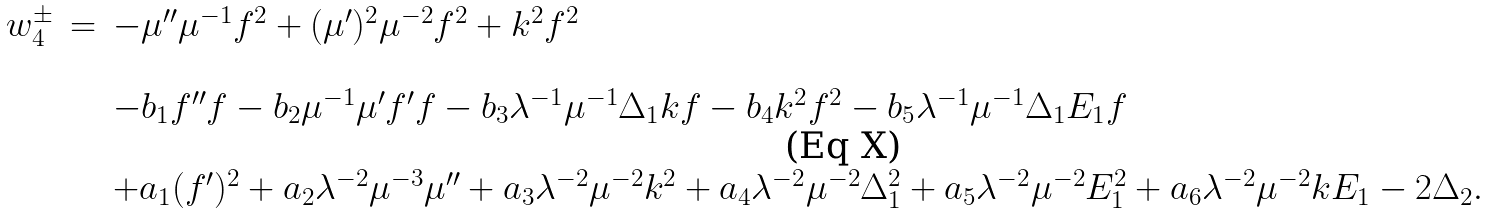Convert formula to latex. <formula><loc_0><loc_0><loc_500><loc_500>\begin{array} { l l l } w _ { 4 } ^ { \pm } & = & - \mu ^ { \prime \prime } \mu ^ { - 1 } f ^ { 2 } + ( \mu ^ { \prime } ) ^ { 2 } \mu ^ { - 2 } f ^ { 2 } + k ^ { 2 } f ^ { 2 } \\ & & \\ & & - b _ { 1 } f ^ { \prime \prime } f - b _ { 2 } \mu ^ { - 1 } \mu ^ { \prime } f ^ { \prime } f - b _ { 3 } \lambda ^ { - 1 } \mu ^ { - 1 } \Delta _ { 1 } k f - b _ { 4 } k ^ { 2 } f ^ { 2 } - b _ { 5 } \lambda ^ { - 1 } \mu ^ { - 1 } \Delta _ { 1 } E _ { 1 } f \\ & & \\ & & + a _ { 1 } ( f ^ { \prime } ) ^ { 2 } + a _ { 2 } \lambda ^ { - 2 } \mu ^ { - 3 } \mu ^ { \prime \prime } + a _ { 3 } \lambda ^ { - 2 } \mu ^ { - 2 } k ^ { 2 } + a _ { 4 } \lambda ^ { - 2 } \mu ^ { - 2 } \Delta _ { 1 } ^ { 2 } + a _ { 5 } \lambda ^ { - 2 } \mu ^ { - 2 } E _ { 1 } ^ { 2 } + a _ { 6 } \lambda ^ { - 2 } \mu ^ { - 2 } k E _ { 1 } - 2 \Delta _ { 2 } . \end{array}</formula> 